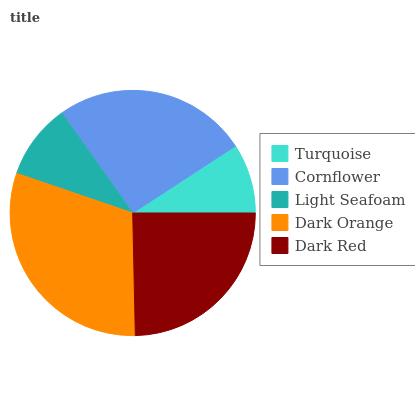Is Turquoise the minimum?
Answer yes or no. Yes. Is Dark Orange the maximum?
Answer yes or no. Yes. Is Cornflower the minimum?
Answer yes or no. No. Is Cornflower the maximum?
Answer yes or no. No. Is Cornflower greater than Turquoise?
Answer yes or no. Yes. Is Turquoise less than Cornflower?
Answer yes or no. Yes. Is Turquoise greater than Cornflower?
Answer yes or no. No. Is Cornflower less than Turquoise?
Answer yes or no. No. Is Dark Red the high median?
Answer yes or no. Yes. Is Dark Red the low median?
Answer yes or no. Yes. Is Turquoise the high median?
Answer yes or no. No. Is Light Seafoam the low median?
Answer yes or no. No. 